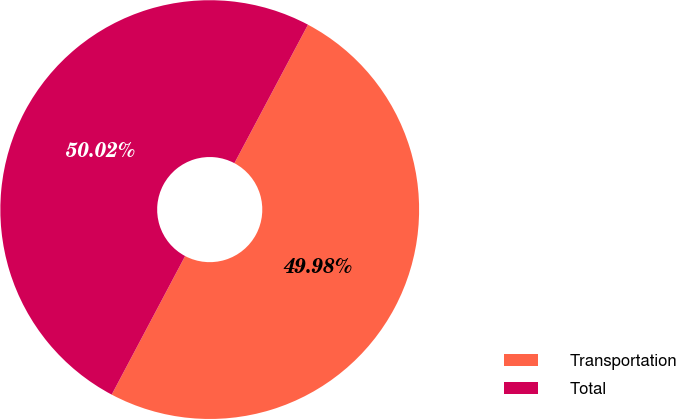Convert chart to OTSL. <chart><loc_0><loc_0><loc_500><loc_500><pie_chart><fcel>Transportation<fcel>Total<nl><fcel>49.98%<fcel>50.02%<nl></chart> 